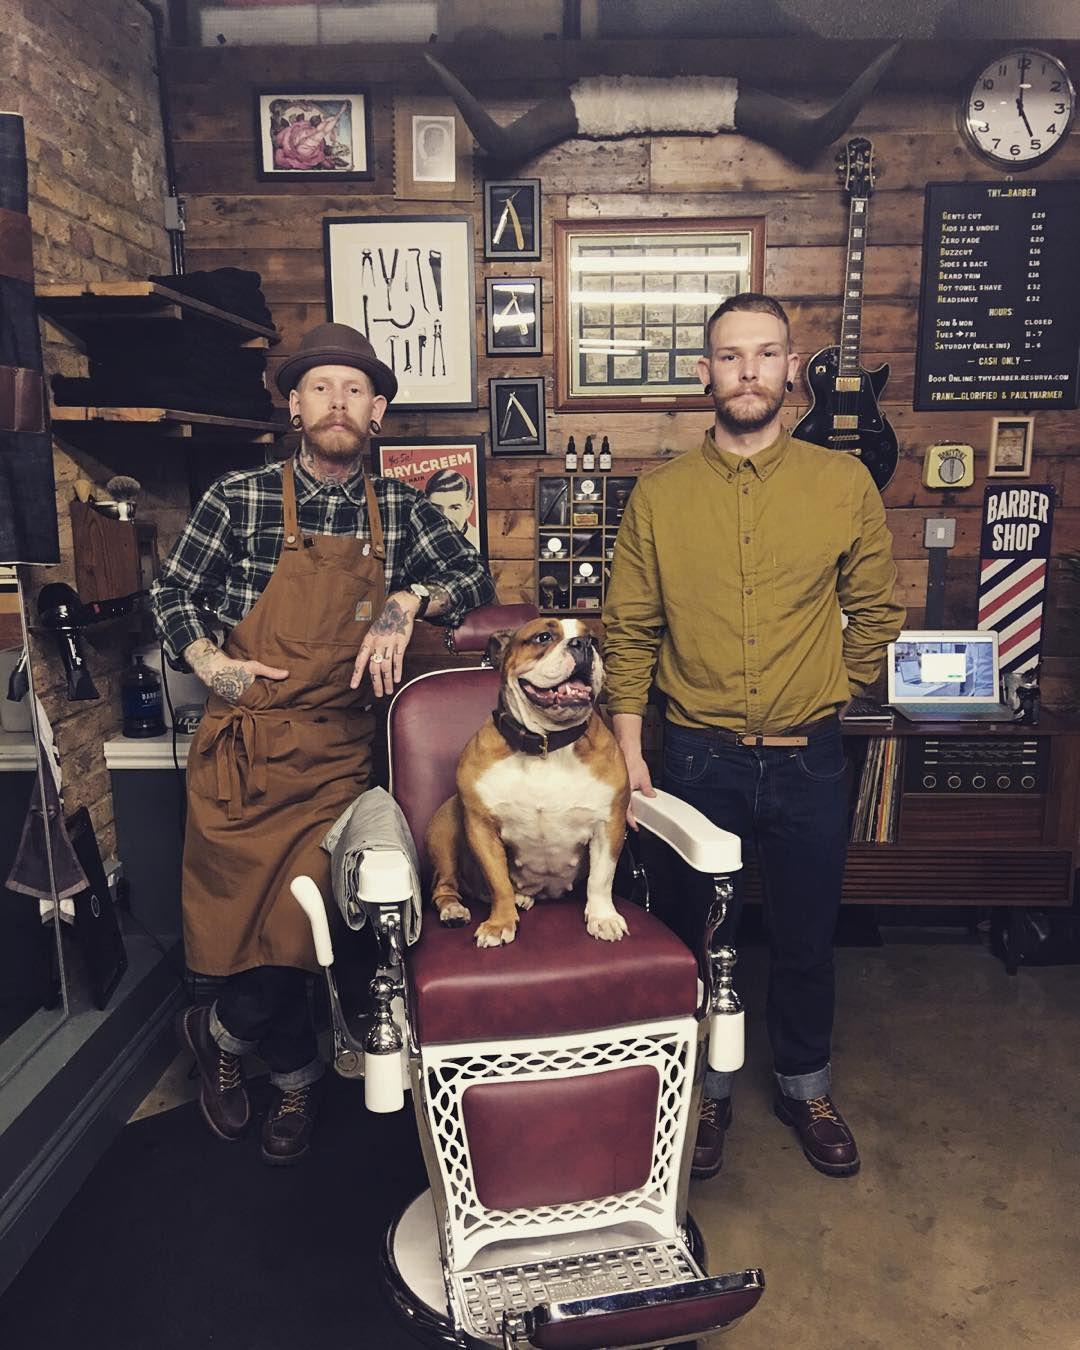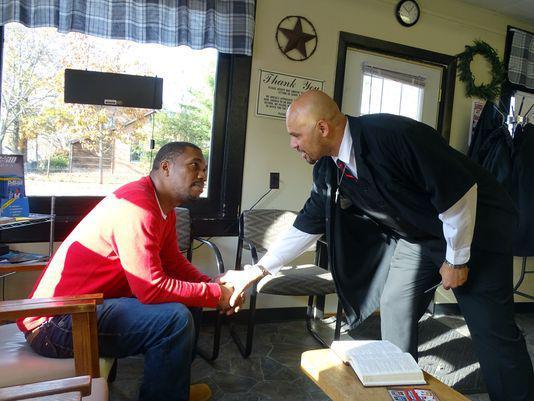The first image is the image on the left, the second image is the image on the right. Considering the images on both sides, is "The left and right image contains a total of four men in a barber shop." valid? Answer yes or no. Yes. The first image is the image on the left, the second image is the image on the right. Evaluate the accuracy of this statement regarding the images: "Exactly two men in the barber shop are clean shaven.". Is it true? Answer yes or no. No. 